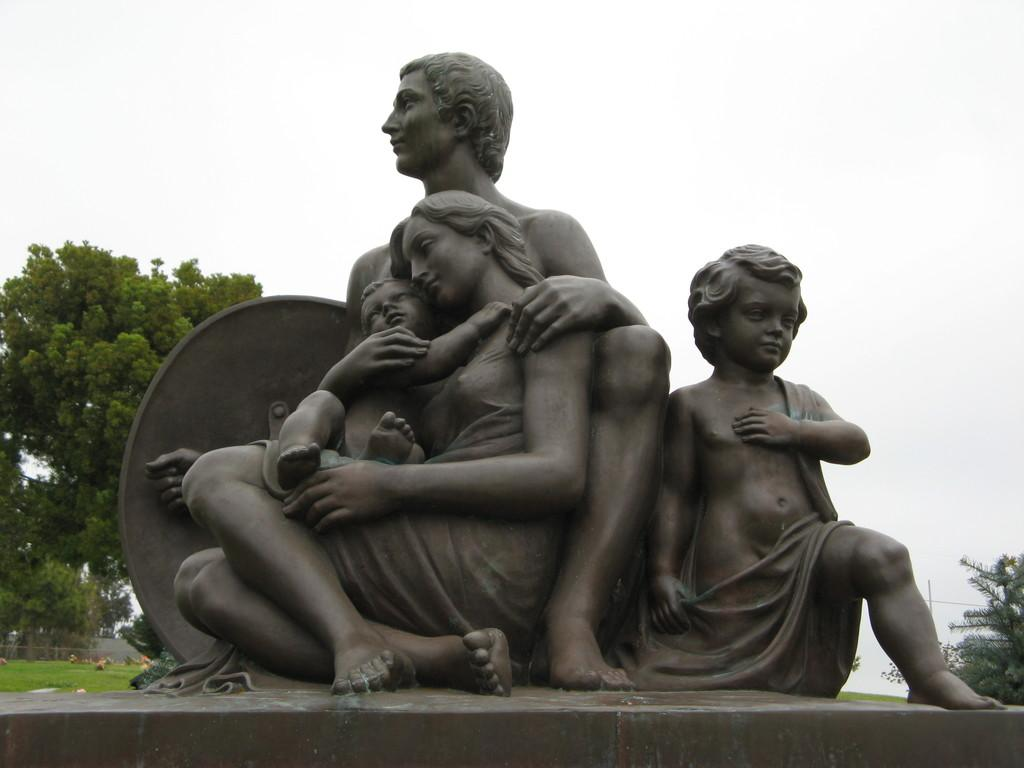What can be seen in the image that represents artistic creations? There are statues in the image. What type of natural environment is visible in the background of the image? There are trees and grass in the background of the image. What is visible in the sky in the image? The sky is visible in the background of the image. What type of material is the minister made of in the image? There is no minister present in the image, so it is not possible to determine the material it might be made of. 